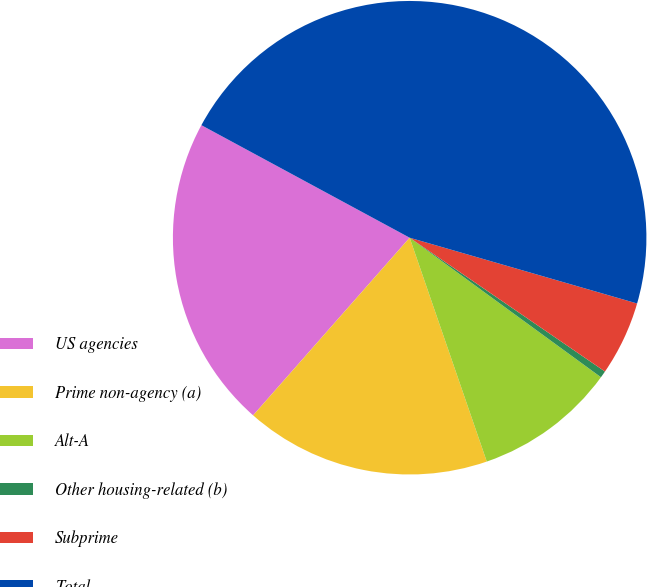Convert chart. <chart><loc_0><loc_0><loc_500><loc_500><pie_chart><fcel>US agencies<fcel>Prime non-agency (a)<fcel>Alt-A<fcel>Other housing-related (b)<fcel>Subprime<fcel>Total<nl><fcel>21.39%<fcel>16.78%<fcel>9.69%<fcel>0.47%<fcel>5.08%<fcel>46.6%<nl></chart> 